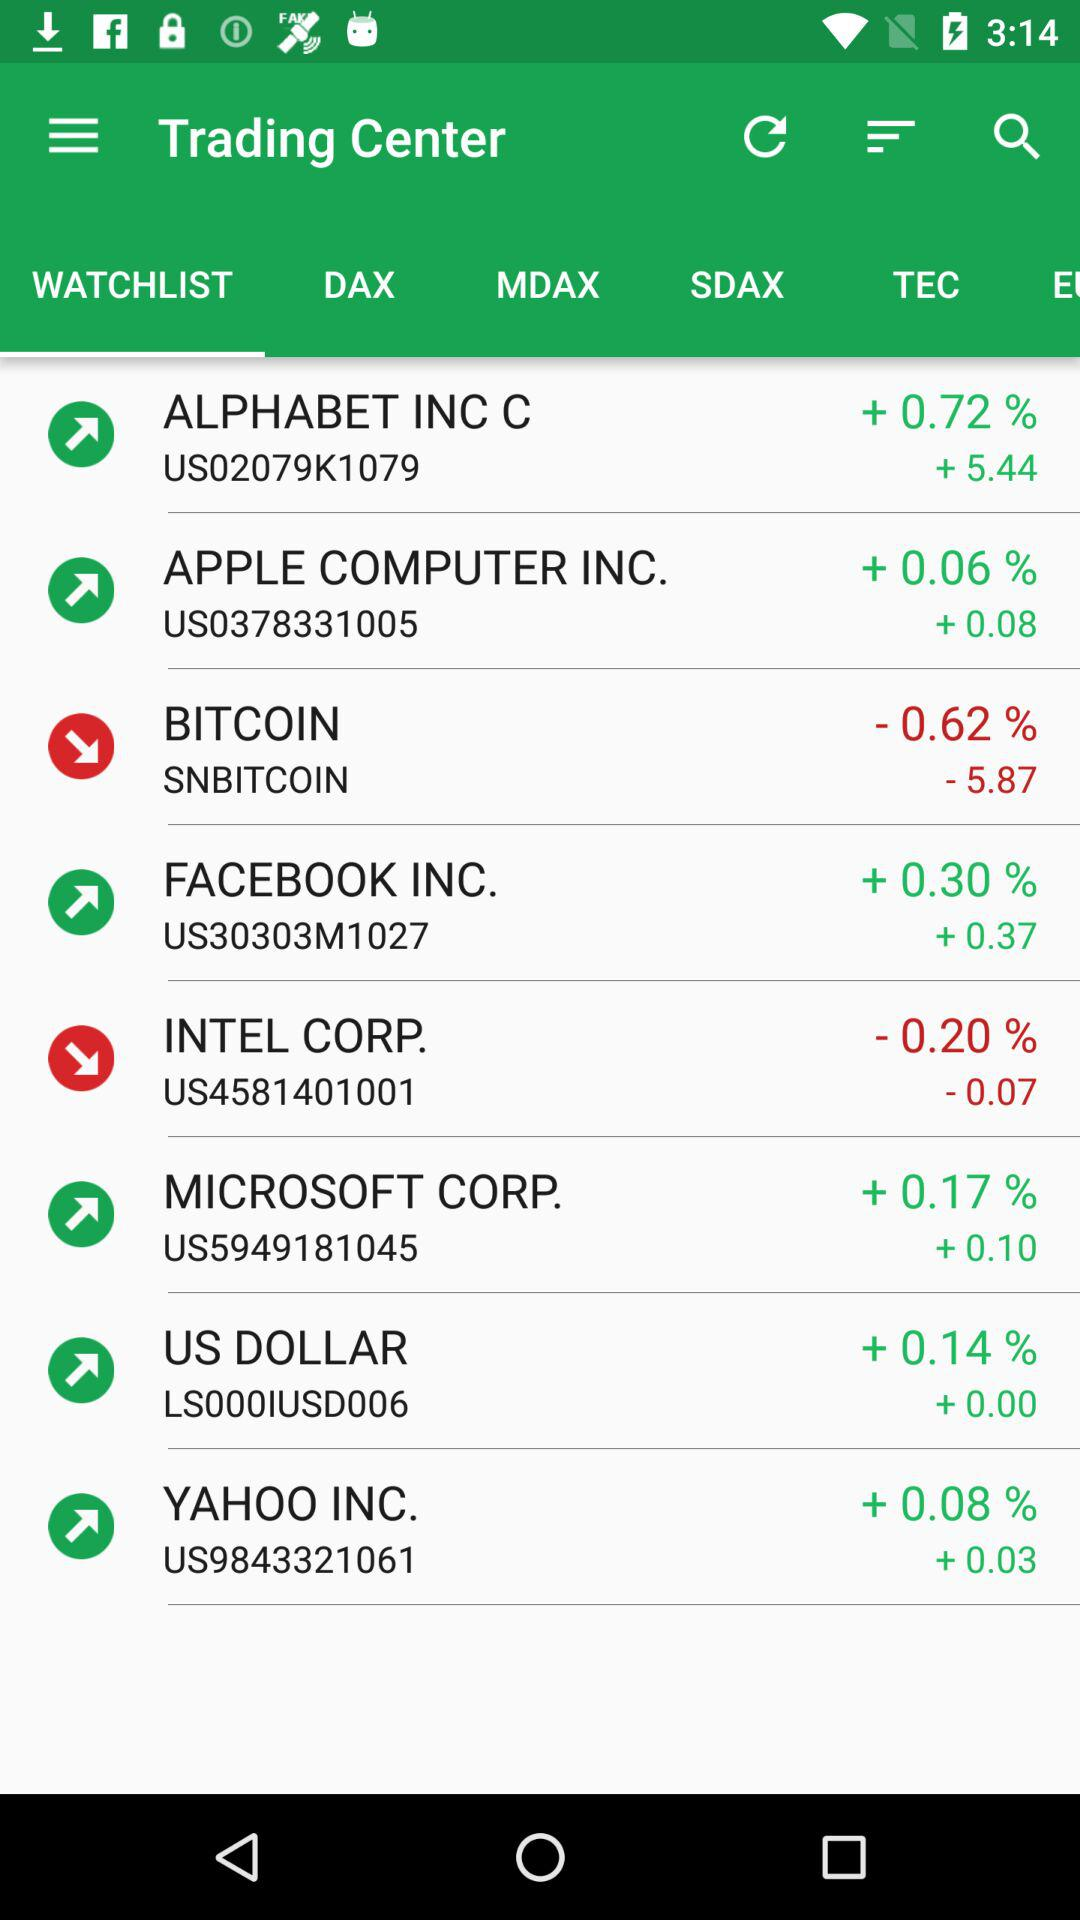How many companies have a negative percentage change?
Answer the question using a single word or phrase. 2 